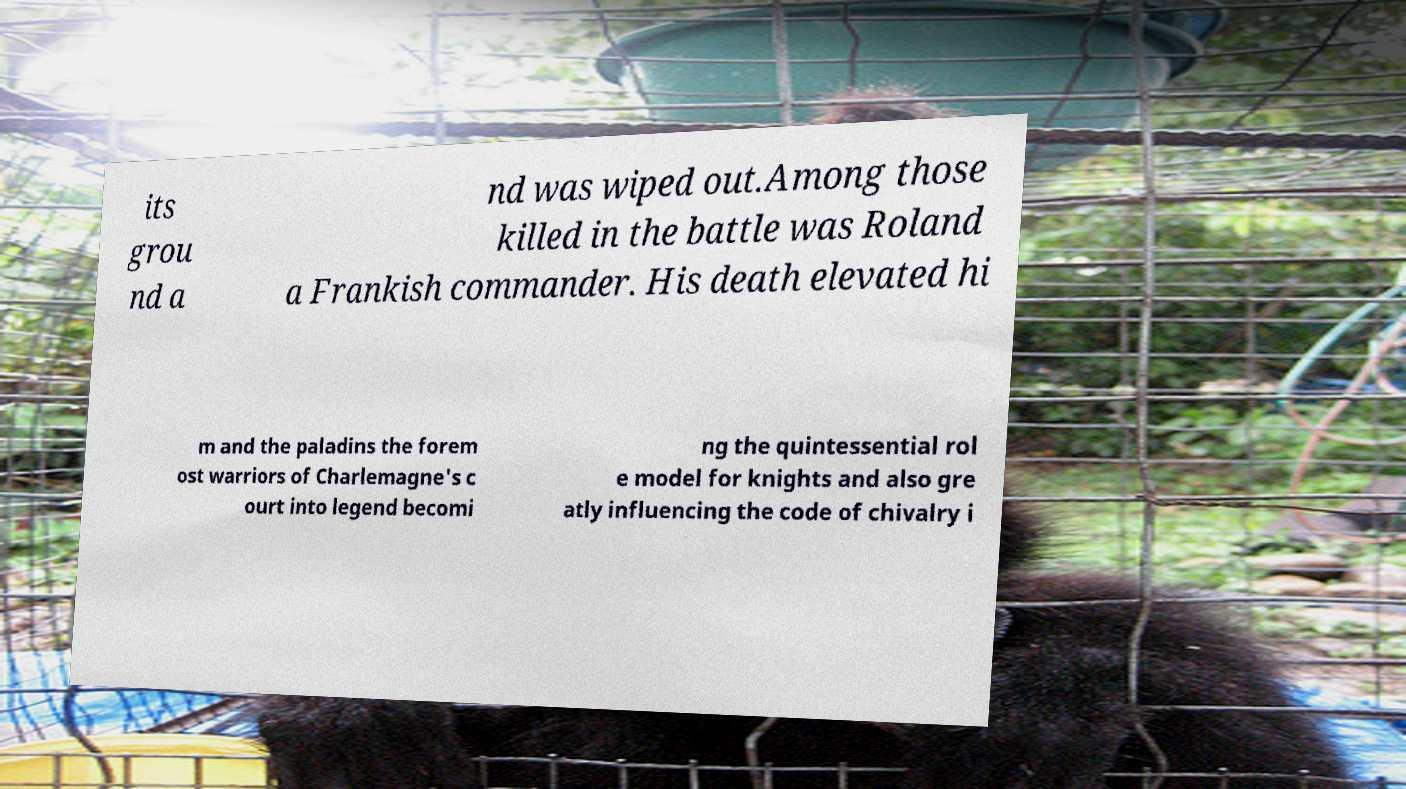There's text embedded in this image that I need extracted. Can you transcribe it verbatim? its grou nd a nd was wiped out.Among those killed in the battle was Roland a Frankish commander. His death elevated hi m and the paladins the forem ost warriors of Charlemagne's c ourt into legend becomi ng the quintessential rol e model for knights and also gre atly influencing the code of chivalry i 